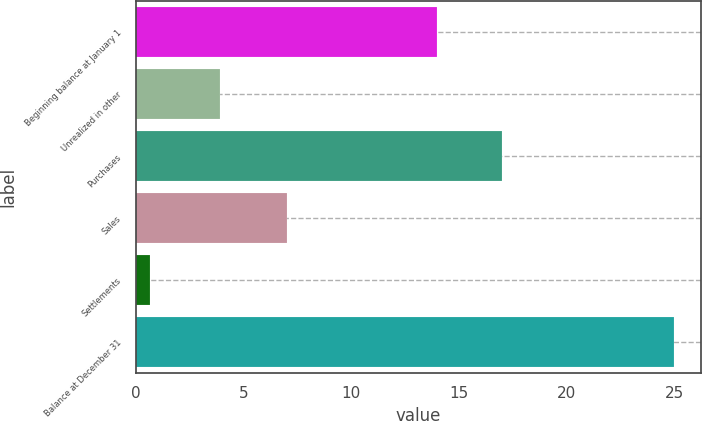Convert chart to OTSL. <chart><loc_0><loc_0><loc_500><loc_500><bar_chart><fcel>Beginning balance at January 1<fcel>Unrealized in other<fcel>Purchases<fcel>Sales<fcel>Settlements<fcel>Balance at December 31<nl><fcel>14<fcel>3.9<fcel>17<fcel>7<fcel>0.64<fcel>25<nl></chart> 